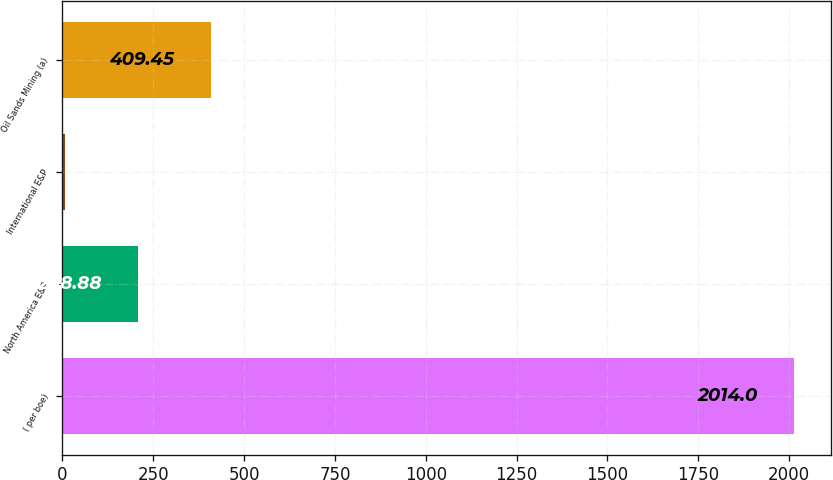<chart> <loc_0><loc_0><loc_500><loc_500><bar_chart><fcel>( per boe)<fcel>North America E&P<fcel>International E&P<fcel>Oil Sands Mining (a)<nl><fcel>2014<fcel>208.88<fcel>8.31<fcel>409.45<nl></chart> 